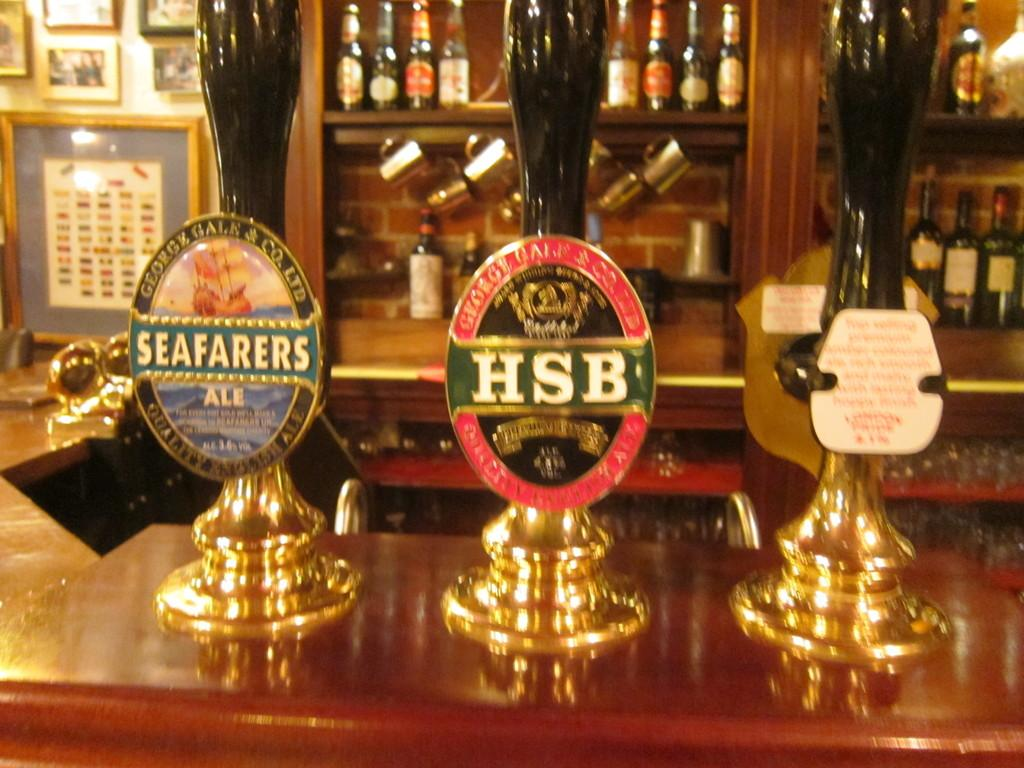<image>
Create a compact narrative representing the image presented. Multiple taps of beer sit atop a bar counter including one for Seafarers Ale. 